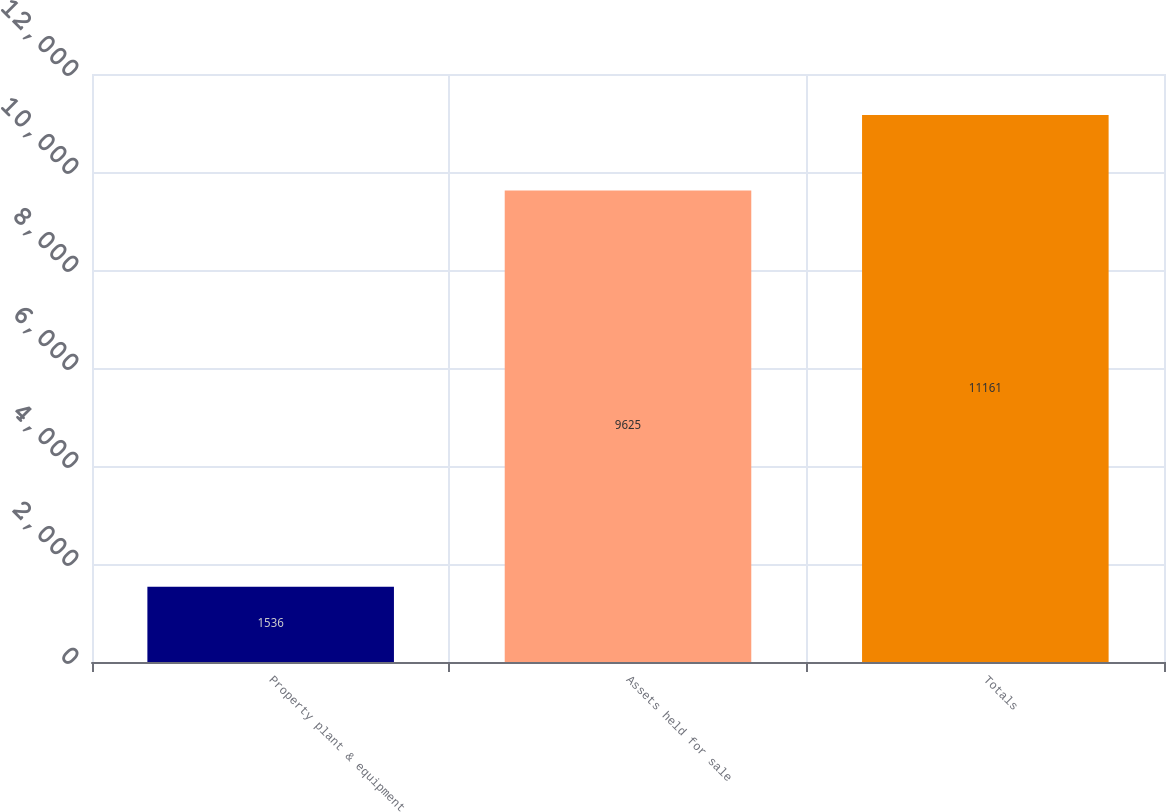Convert chart. <chart><loc_0><loc_0><loc_500><loc_500><bar_chart><fcel>Property plant & equipment<fcel>Assets held for sale<fcel>Totals<nl><fcel>1536<fcel>9625<fcel>11161<nl></chart> 